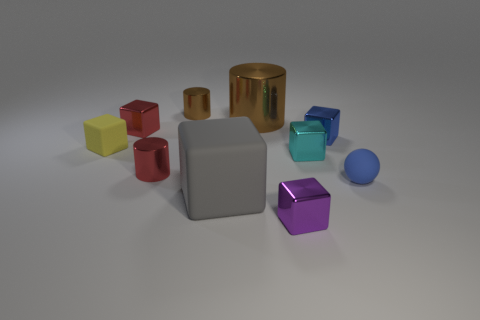Subtract all small yellow rubber blocks. How many blocks are left? 5 Subtract all spheres. How many objects are left? 9 Subtract 3 blocks. How many blocks are left? 3 Subtract all small purple things. Subtract all small red shiny cubes. How many objects are left? 8 Add 1 big brown things. How many big brown things are left? 2 Add 7 blue shiny cubes. How many blue shiny cubes exist? 8 Subtract all red cylinders. How many cylinders are left? 2 Subtract 0 green spheres. How many objects are left? 10 Subtract all gray blocks. Subtract all gray balls. How many blocks are left? 5 Subtract all cyan cubes. How many cyan spheres are left? 0 